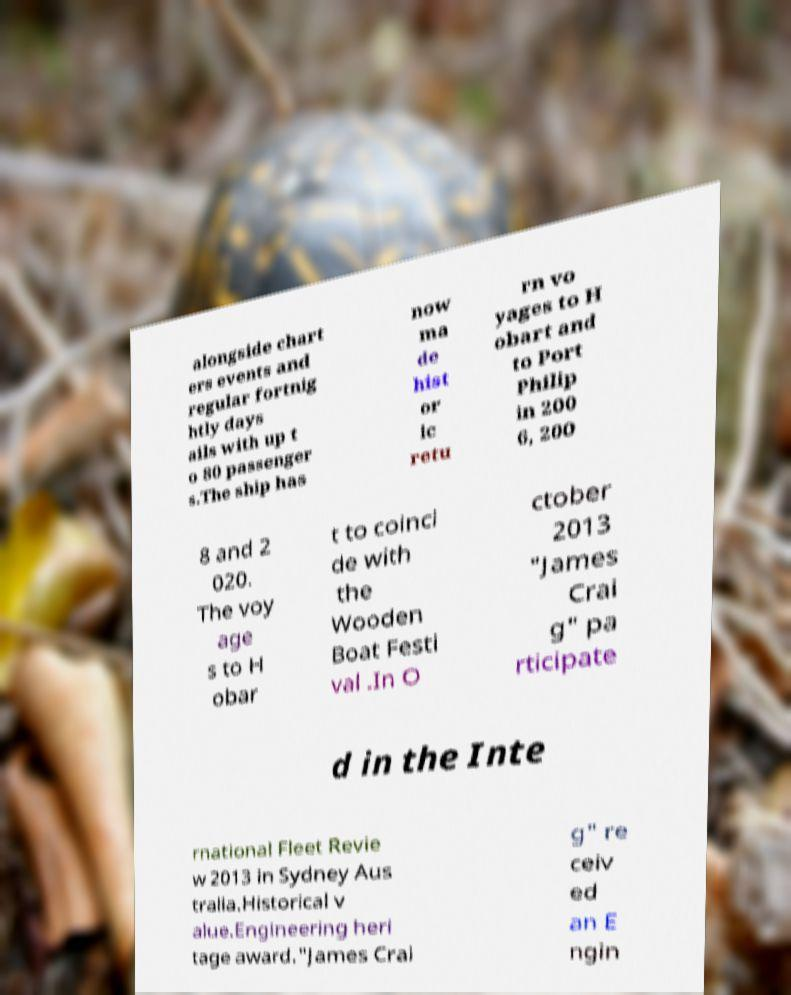For documentation purposes, I need the text within this image transcribed. Could you provide that? alongside chart ers events and regular fortnig htly days ails with up t o 80 passenger s.The ship has now ma de hist or ic retu rn vo yages to H obart and to Port Philip in 200 6, 200 8 and 2 020. The voy age s to H obar t to coinci de with the Wooden Boat Festi val .In O ctober 2013 "James Crai g" pa rticipate d in the Inte rnational Fleet Revie w 2013 in Sydney Aus tralia.Historical v alue.Engineering heri tage award."James Crai g" re ceiv ed an E ngin 